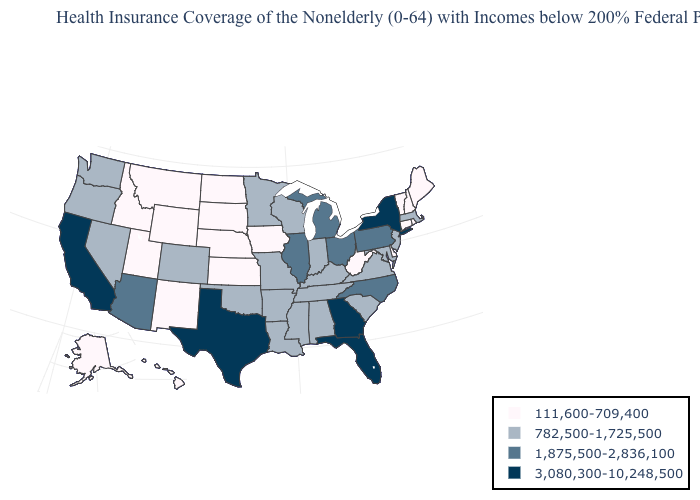What is the value of California?
Answer briefly. 3,080,300-10,248,500. Which states have the lowest value in the USA?
Quick response, please. Alaska, Connecticut, Delaware, Hawaii, Idaho, Iowa, Kansas, Maine, Montana, Nebraska, New Hampshire, New Mexico, North Dakota, Rhode Island, South Dakota, Utah, Vermont, West Virginia, Wyoming. What is the value of Idaho?
Quick response, please. 111,600-709,400. Name the states that have a value in the range 1,875,500-2,836,100?
Quick response, please. Arizona, Illinois, Michigan, North Carolina, Ohio, Pennsylvania. Does Arizona have a higher value than Pennsylvania?
Write a very short answer. No. Does the map have missing data?
Keep it brief. No. What is the highest value in the Northeast ?
Quick response, please. 3,080,300-10,248,500. How many symbols are there in the legend?
Be succinct. 4. What is the value of Tennessee?
Quick response, please. 782,500-1,725,500. What is the value of Missouri?
Keep it brief. 782,500-1,725,500. Among the states that border Wyoming , does Idaho have the highest value?
Give a very brief answer. No. Which states have the lowest value in the USA?
Answer briefly. Alaska, Connecticut, Delaware, Hawaii, Idaho, Iowa, Kansas, Maine, Montana, Nebraska, New Hampshire, New Mexico, North Dakota, Rhode Island, South Dakota, Utah, Vermont, West Virginia, Wyoming. Does Georgia have the highest value in the USA?
Keep it brief. Yes. What is the lowest value in the USA?
Short answer required. 111,600-709,400. What is the value of Kentucky?
Be succinct. 782,500-1,725,500. 